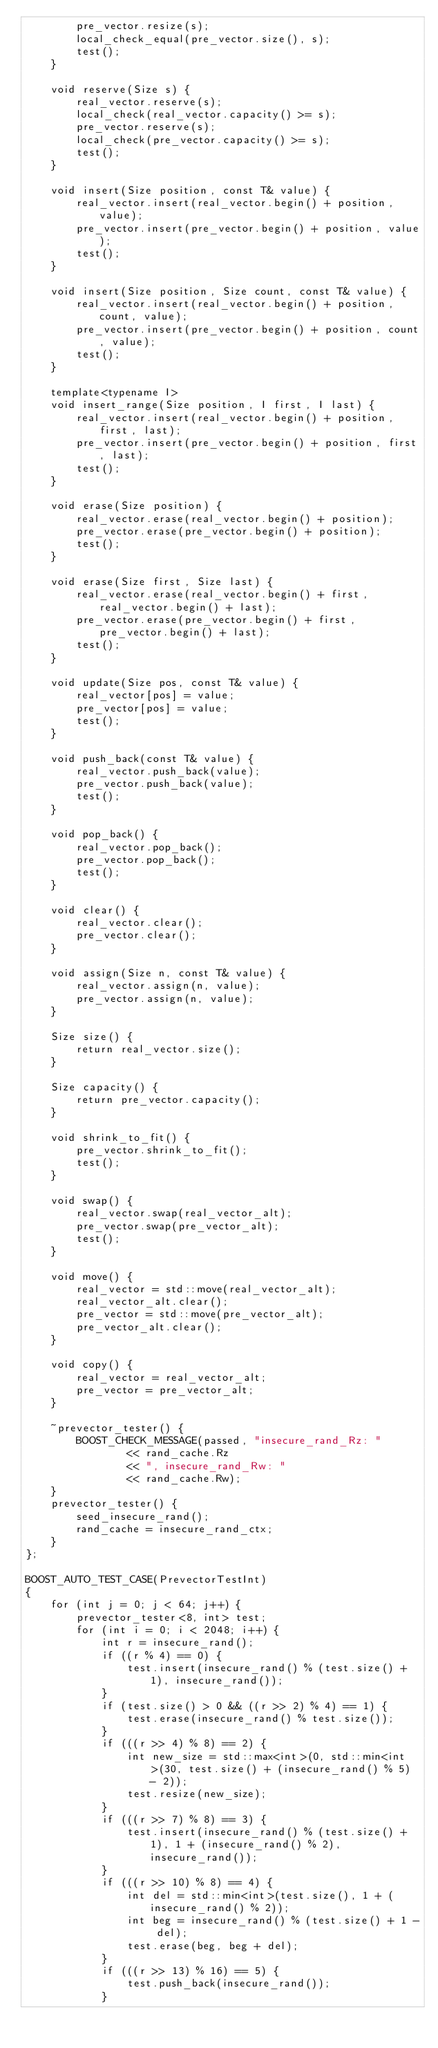Convert code to text. <code><loc_0><loc_0><loc_500><loc_500><_C++_>        pre_vector.resize(s);
        local_check_equal(pre_vector.size(), s);
        test();
    }

    void reserve(Size s) {
        real_vector.reserve(s);
        local_check(real_vector.capacity() >= s);
        pre_vector.reserve(s);
        local_check(pre_vector.capacity() >= s);
        test();
    }

    void insert(Size position, const T& value) {
        real_vector.insert(real_vector.begin() + position, value);
        pre_vector.insert(pre_vector.begin() + position, value);
        test();
    }

    void insert(Size position, Size count, const T& value) {
        real_vector.insert(real_vector.begin() + position, count, value);
        pre_vector.insert(pre_vector.begin() + position, count, value);
        test();
    }

    template<typename I>
    void insert_range(Size position, I first, I last) {
        real_vector.insert(real_vector.begin() + position, first, last);
        pre_vector.insert(pre_vector.begin() + position, first, last);
        test();
    }

    void erase(Size position) {
        real_vector.erase(real_vector.begin() + position);
        pre_vector.erase(pre_vector.begin() + position);
        test();
    }

    void erase(Size first, Size last) {
        real_vector.erase(real_vector.begin() + first, real_vector.begin() + last);
        pre_vector.erase(pre_vector.begin() + first, pre_vector.begin() + last);
        test();
    }

    void update(Size pos, const T& value) {
        real_vector[pos] = value;
        pre_vector[pos] = value;
        test();
    }

    void push_back(const T& value) {
        real_vector.push_back(value);
        pre_vector.push_back(value);
        test();
    }

    void pop_back() {
        real_vector.pop_back();
        pre_vector.pop_back();
        test();
    }

    void clear() {
        real_vector.clear();
        pre_vector.clear();
    }

    void assign(Size n, const T& value) {
        real_vector.assign(n, value);
        pre_vector.assign(n, value);
    }

    Size size() {
        return real_vector.size();
    }

    Size capacity() {
        return pre_vector.capacity();
    }

    void shrink_to_fit() {
        pre_vector.shrink_to_fit();
        test();
    }

    void swap() {
        real_vector.swap(real_vector_alt);
        pre_vector.swap(pre_vector_alt);
        test();
    }

    void move() {
        real_vector = std::move(real_vector_alt);
        real_vector_alt.clear();
        pre_vector = std::move(pre_vector_alt);
        pre_vector_alt.clear();
    }

    void copy() {
        real_vector = real_vector_alt;
        pre_vector = pre_vector_alt;
    }

    ~prevector_tester() {
        BOOST_CHECK_MESSAGE(passed, "insecure_rand_Rz: "
                << rand_cache.Rz
                << ", insecure_rand_Rw: "
                << rand_cache.Rw);
    }
    prevector_tester() {
        seed_insecure_rand();
        rand_cache = insecure_rand_ctx;
    }
};

BOOST_AUTO_TEST_CASE(PrevectorTestInt)
{
    for (int j = 0; j < 64; j++) {
        prevector_tester<8, int> test;
        for (int i = 0; i < 2048; i++) {
            int r = insecure_rand();
            if ((r % 4) == 0) {
                test.insert(insecure_rand() % (test.size() + 1), insecure_rand());
            }
            if (test.size() > 0 && ((r >> 2) % 4) == 1) {
                test.erase(insecure_rand() % test.size());
            }
            if (((r >> 4) % 8) == 2) {
                int new_size = std::max<int>(0, std::min<int>(30, test.size() + (insecure_rand() % 5) - 2));
                test.resize(new_size);
            }
            if (((r >> 7) % 8) == 3) {
                test.insert(insecure_rand() % (test.size() + 1), 1 + (insecure_rand() % 2), insecure_rand());
            }
            if (((r >> 10) % 8) == 4) {
                int del = std::min<int>(test.size(), 1 + (insecure_rand() % 2));
                int beg = insecure_rand() % (test.size() + 1 - del);
                test.erase(beg, beg + del);
            }
            if (((r >> 13) % 16) == 5) {
                test.push_back(insecure_rand());
            }</code> 